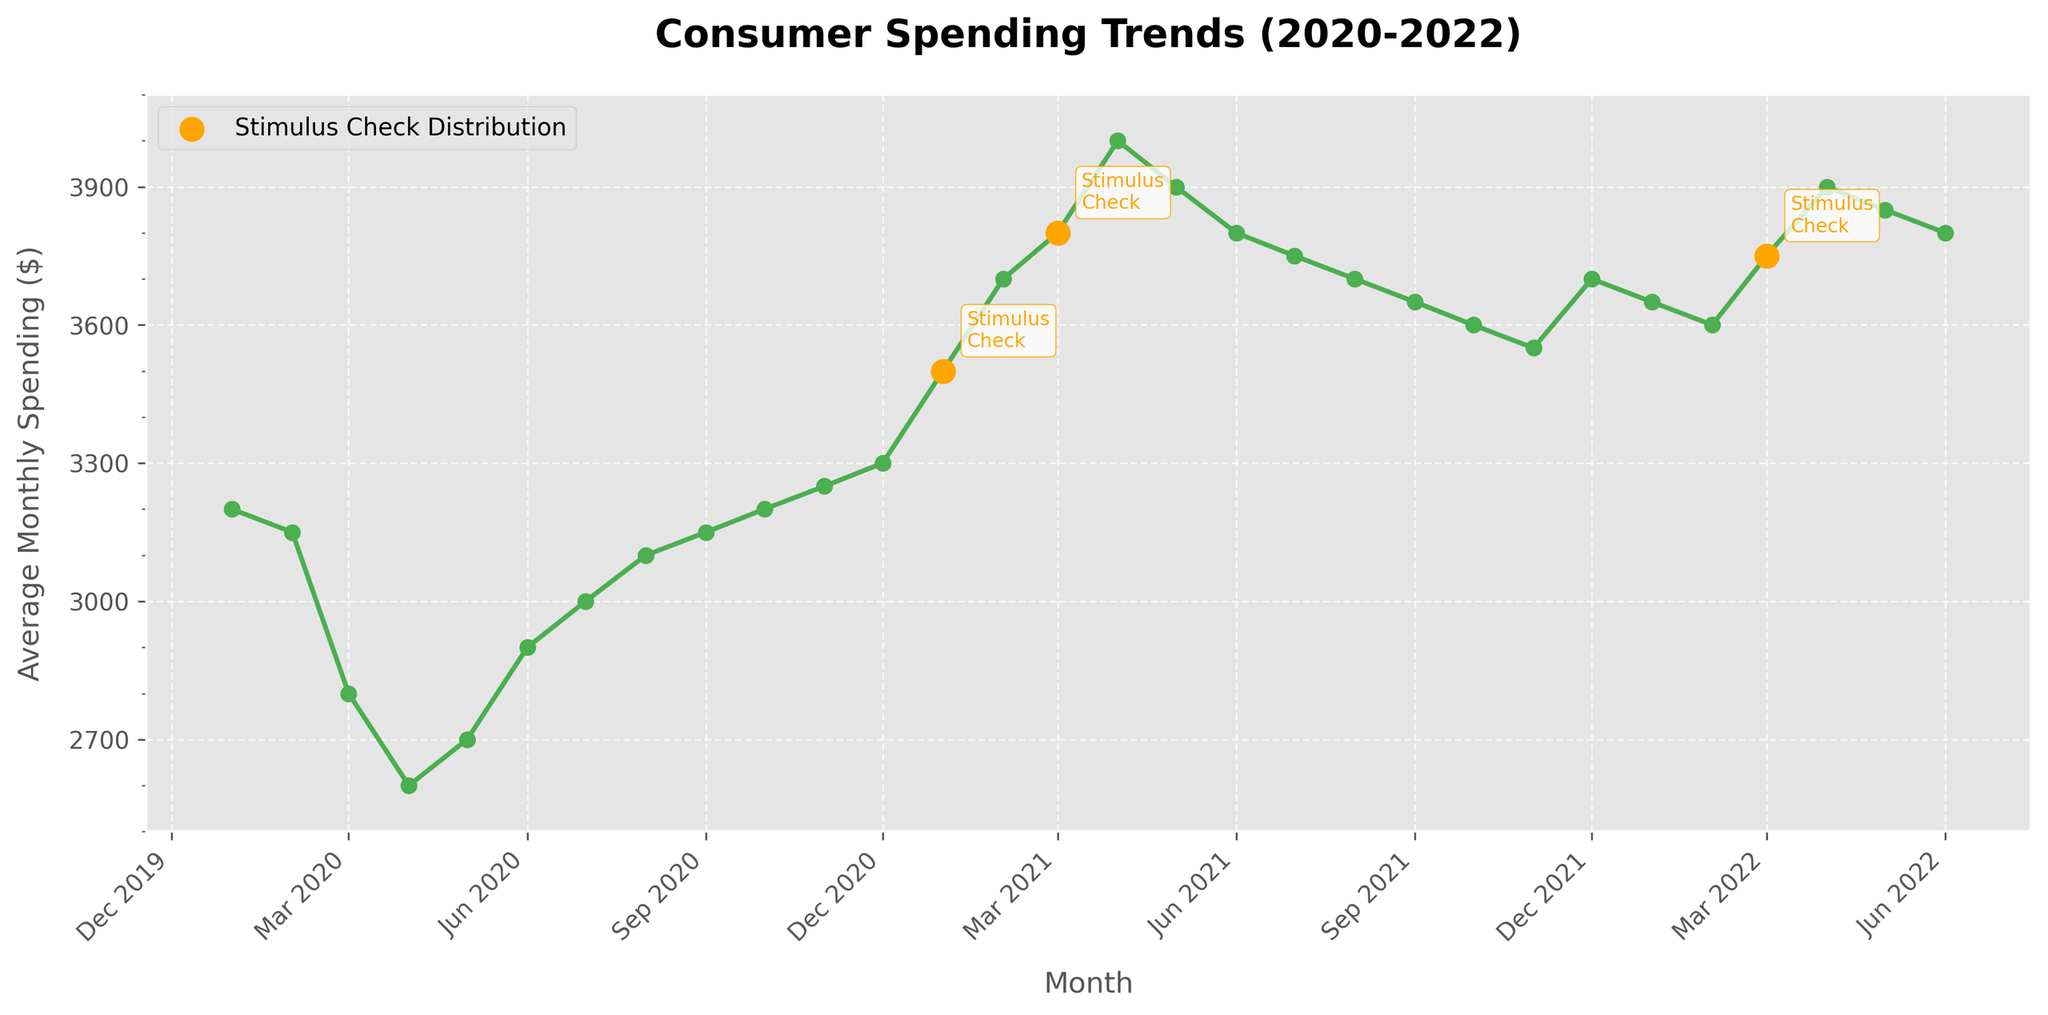What trend in consumer spending is observed immediately after the stimulus checks distributions? Comparing the data points before and after January 2021, March 2021, and March 2022, consumer spending shows a noticeable increase immediately following these periods.
Answer: Increase How does consumer spending in January 2021 compare with February 2021? By observing the data points marked by the yellow dots (indicative of stimulus check distribution), spending in January 2021 ($3500) increased in February 2021 ($3700).
Answer: February 2021 is higher What is the difference in spending between April 2020 and January 2021? April 2020 spending was $2600, while January 2021 spending was $3500. The difference is $3500 - $2600 = $900.
Answer: $900 Is there a stimulus check distribution month that did not lead to an increase in spending immediately the following month? Checking the stimulus check periods and subsequent months, March 2021 ($3800) was followed by a decrease in April 2021 ($4000 to $3900).
Answer: No What visual indicator is used to highlight the months when stimulus checks were distributed? The months with stimulus checks are highlighted by larger yellow markers.
Answer: Larger yellow markers What is the range of average monthly spending values depicted in the figure? The lowest value is in April 2020 ($2600), and the highest value is in April 2021 ($4000). Thus, the range is $4000 - $2600 = $1400.
Answer: $1400 What month in 2020 shows the lowest average monthly spending, and what might be the visual cause? April 2020 shows the lowest spending, visually indicated by the lowest point on the green line.
Answer: April 2020 Between which months in 2021 did consumer spending exhibit the highest decline? Spending drops from April 2021 ($4000) to May 2021 ($3900). The decline is $100.
Answer: April 2021 to May 2021 Does the consumer spending trend in 2022 differ visually from 2021? Observing the figures side-by-side, 2022 shows less variation and a slightly declining trend compared to 2021's steep increases.
Answer: Yes What can be concluded about the trend from October 2021 to February 2022? There is a consistent decline from October 2021 ($3600) to February 2022 ($3600), visualized by a downward trend in the line.
Answer: Decline What striking trend is observed for the month of March across all three years? March 2020 drops, March 2021 rises, and March 2022 rises, aligning with stimulus check distributions.
Answer: Increase in 2021 and 2022 